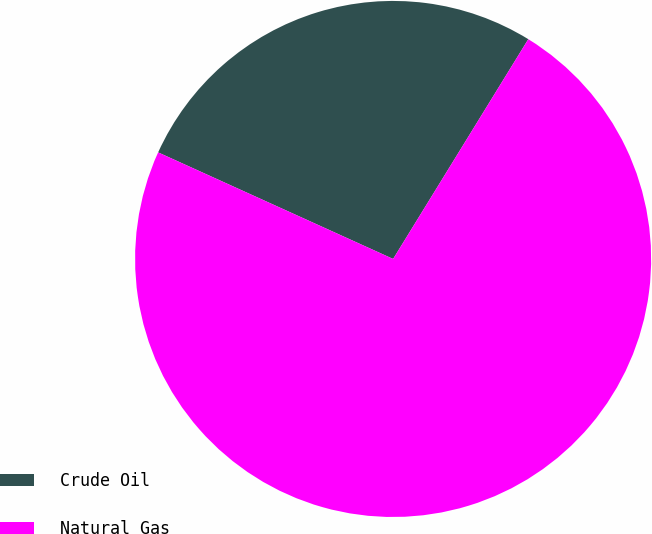Convert chart. <chart><loc_0><loc_0><loc_500><loc_500><pie_chart><fcel>Crude Oil<fcel>Natural Gas<nl><fcel>27.0%<fcel>73.0%<nl></chart> 